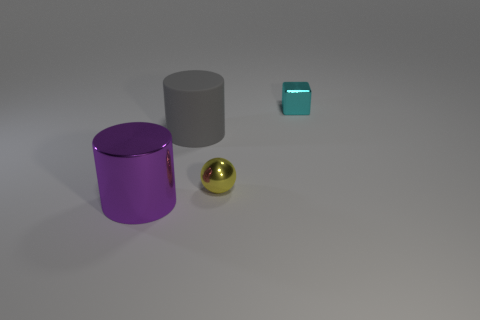Can you describe the texture and material characteristics of the objects in the image? Certainly! The objects in the image exhibit a metallic texture with reflective surfaces. Specifically, the large purple and the gray objects appear to have a smooth matte finish, indicating they could be made of anodized aluminum or a similar metal. The smaller turquoise block has a glossy finish, possibly suggestive of coated steel, while the spherical golden object sports a highly reflective, polished finish, akin to that of polished brass or gold. 